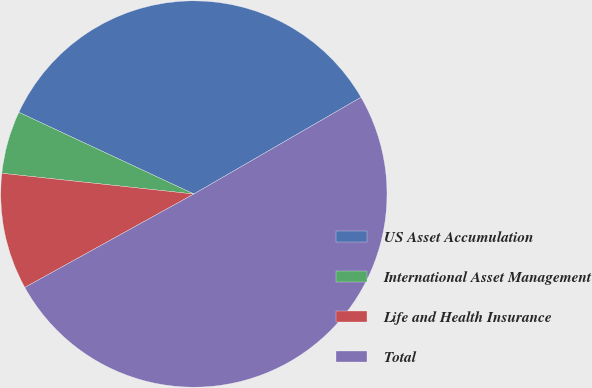<chart> <loc_0><loc_0><loc_500><loc_500><pie_chart><fcel>US Asset Accumulation<fcel>International Asset Management<fcel>Life and Health Insurance<fcel>Total<nl><fcel>34.7%<fcel>5.24%<fcel>9.75%<fcel>50.31%<nl></chart> 